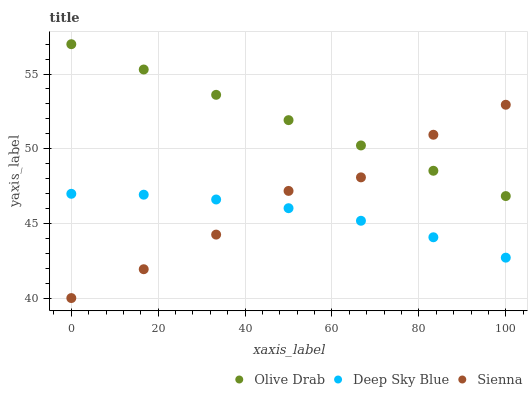Does Deep Sky Blue have the minimum area under the curve?
Answer yes or no. Yes. Does Olive Drab have the maximum area under the curve?
Answer yes or no. Yes. Does Olive Drab have the minimum area under the curve?
Answer yes or no. No. Does Deep Sky Blue have the maximum area under the curve?
Answer yes or no. No. Is Olive Drab the smoothest?
Answer yes or no. Yes. Is Sienna the roughest?
Answer yes or no. Yes. Is Deep Sky Blue the smoothest?
Answer yes or no. No. Is Deep Sky Blue the roughest?
Answer yes or no. No. Does Sienna have the lowest value?
Answer yes or no. Yes. Does Deep Sky Blue have the lowest value?
Answer yes or no. No. Does Olive Drab have the highest value?
Answer yes or no. Yes. Does Deep Sky Blue have the highest value?
Answer yes or no. No. Is Deep Sky Blue less than Olive Drab?
Answer yes or no. Yes. Is Olive Drab greater than Deep Sky Blue?
Answer yes or no. Yes. Does Deep Sky Blue intersect Sienna?
Answer yes or no. Yes. Is Deep Sky Blue less than Sienna?
Answer yes or no. No. Is Deep Sky Blue greater than Sienna?
Answer yes or no. No. Does Deep Sky Blue intersect Olive Drab?
Answer yes or no. No. 